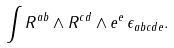Convert formula to latex. <formula><loc_0><loc_0><loc_500><loc_500>\int R ^ { a b } \wedge R ^ { c d } \wedge e ^ { e } \, \epsilon _ { a b c d e } .</formula> 